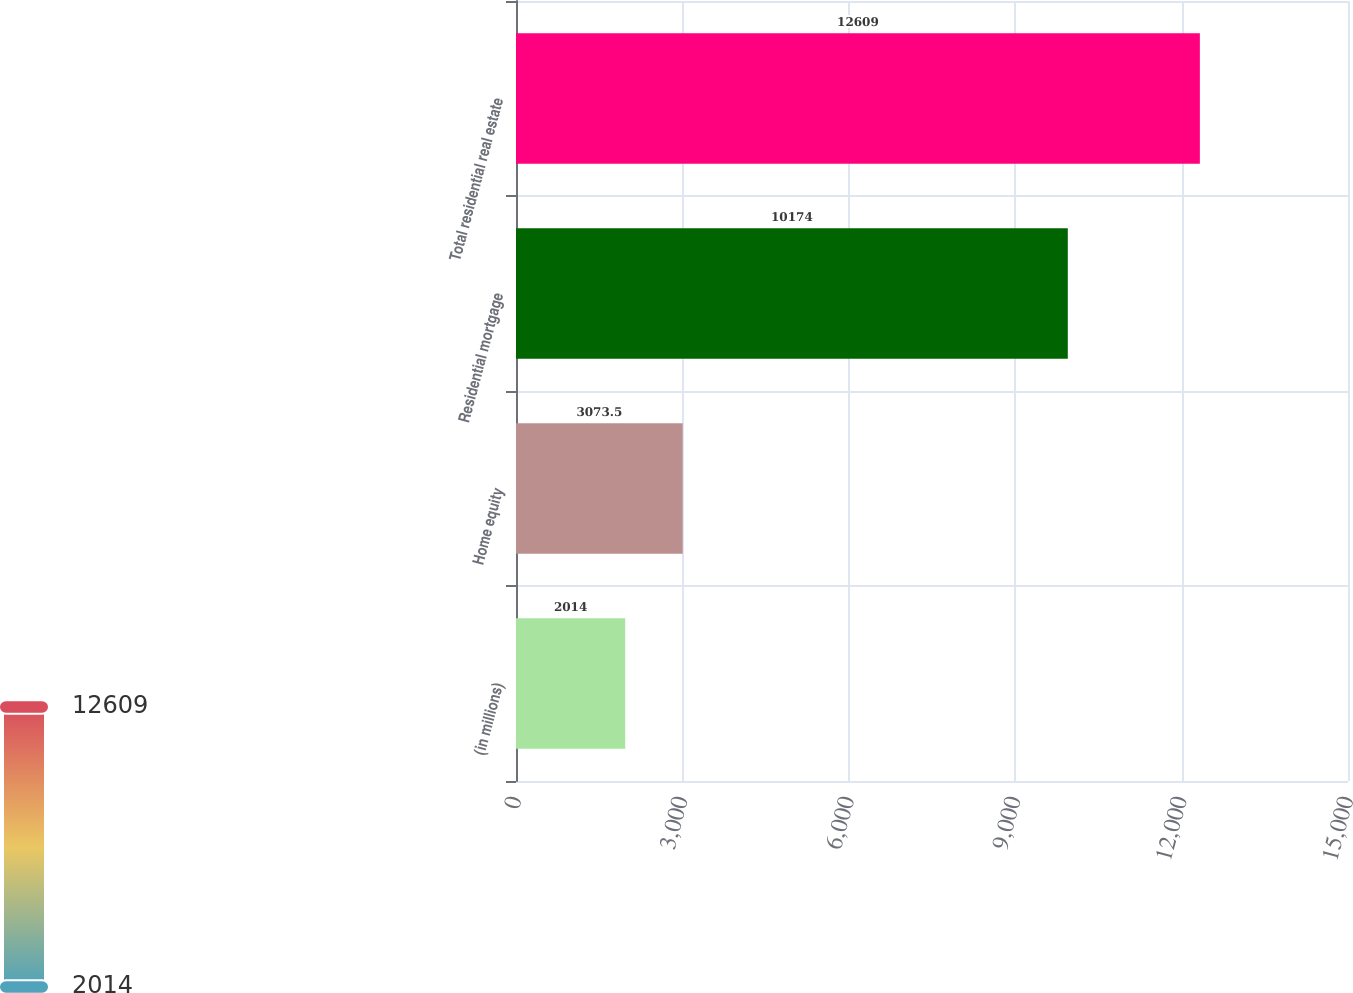<chart> <loc_0><loc_0><loc_500><loc_500><bar_chart><fcel>(in millions)<fcel>Home equity<fcel>Residential mortgage<fcel>Total residential real estate<nl><fcel>2014<fcel>3073.5<fcel>10174<fcel>12609<nl></chart> 